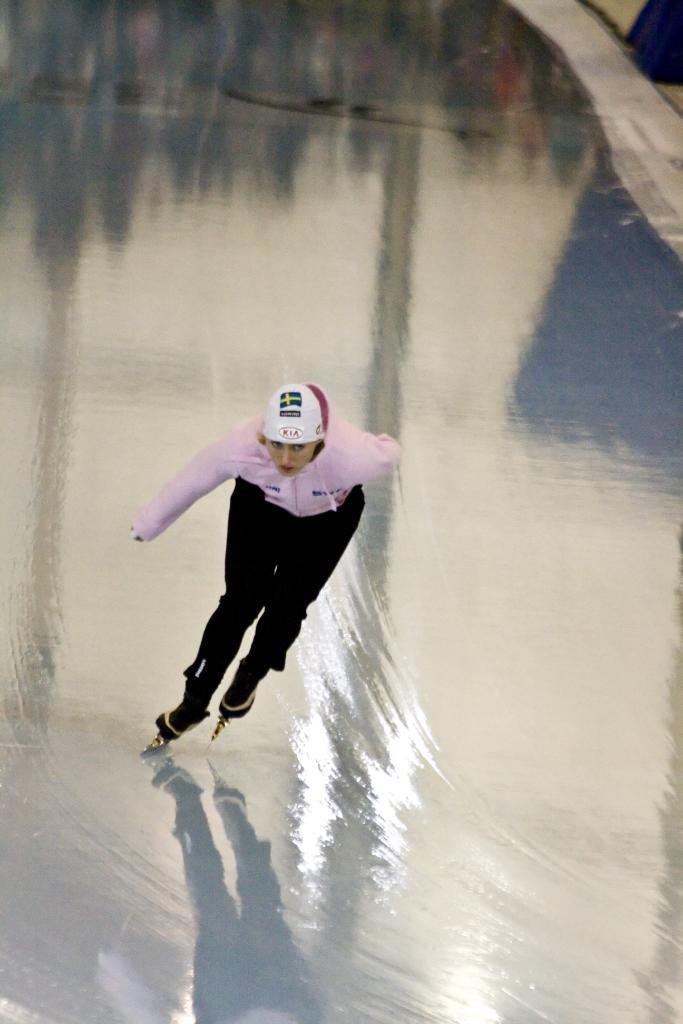Please provide a concise description of this image. In this image a lady wearing helmet is ice skating. On the ground there is ice. 